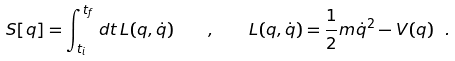<formula> <loc_0><loc_0><loc_500><loc_500>S [ q ] = \int _ { t _ { i } } ^ { t _ { f } } \, d t \, L ( q , \dot { q } ) \quad , \quad L ( q , \dot { q } ) = \frac { 1 } { 2 } m \dot { q } ^ { 2 } - V ( q ) \ .</formula> 